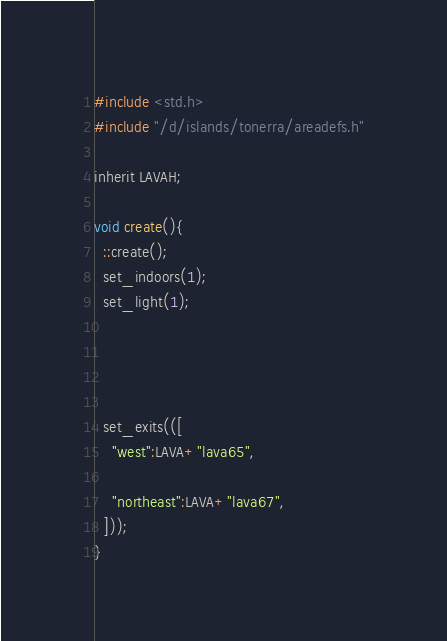Convert code to text. <code><loc_0><loc_0><loc_500><loc_500><_C_>
#include <std.h>
#include "/d/islands/tonerra/areadefs.h"

inherit LAVAH;

void create(){
  ::create();
  set_indoors(1);
  set_light(1);
  
  
  
  
  set_exits(([
    "west":LAVA+"lava65",

    "northeast":LAVA+"lava67",
  ]));
}
</code> 